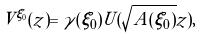<formula> <loc_0><loc_0><loc_500><loc_500>V ^ { \xi _ { 0 } } ( z ) = \gamma ( \xi _ { 0 } ) U ( \sqrt { A ( \xi _ { 0 } ) } z ) ,</formula> 